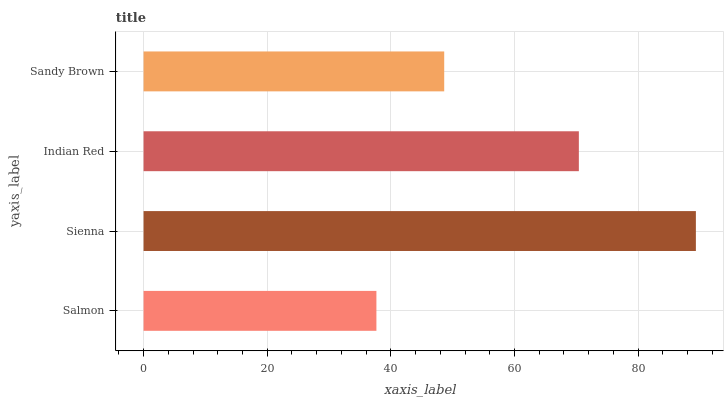Is Salmon the minimum?
Answer yes or no. Yes. Is Sienna the maximum?
Answer yes or no. Yes. Is Indian Red the minimum?
Answer yes or no. No. Is Indian Red the maximum?
Answer yes or no. No. Is Sienna greater than Indian Red?
Answer yes or no. Yes. Is Indian Red less than Sienna?
Answer yes or no. Yes. Is Indian Red greater than Sienna?
Answer yes or no. No. Is Sienna less than Indian Red?
Answer yes or no. No. Is Indian Red the high median?
Answer yes or no. Yes. Is Sandy Brown the low median?
Answer yes or no. Yes. Is Sienna the high median?
Answer yes or no. No. Is Salmon the low median?
Answer yes or no. No. 